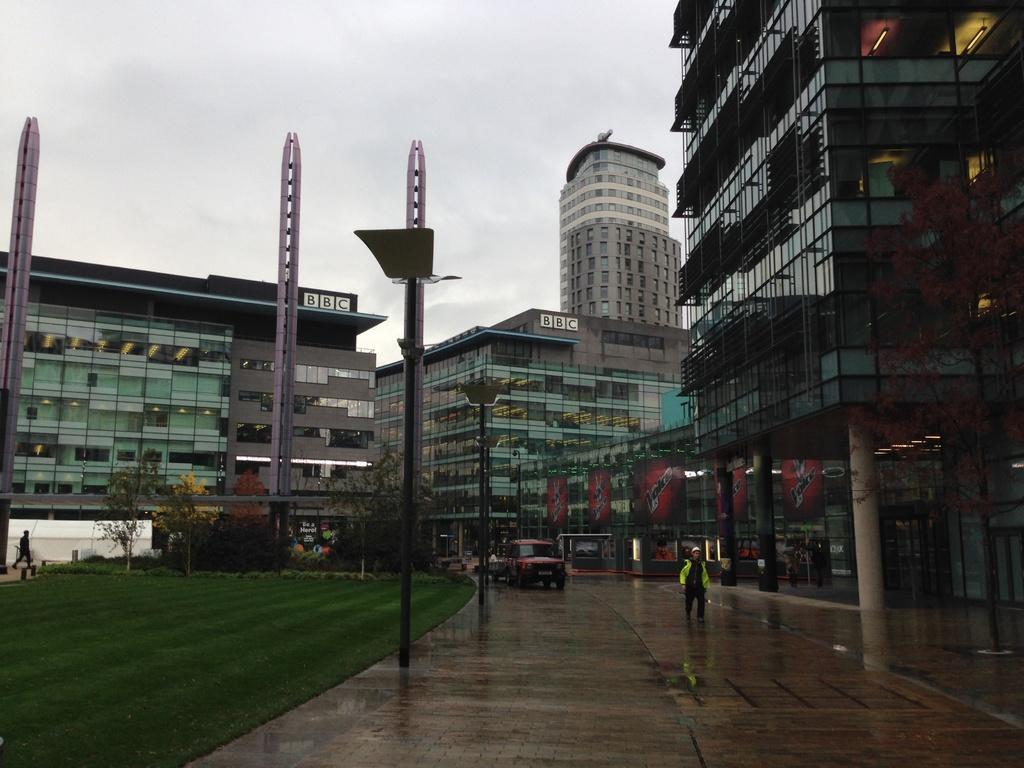Please provide a concise description of this image. In this image there is a road at the bottom. On the road there are vehicles. On the right side there is a man walking on the road by wearing the jacket. In the background there are buildings with the glasses. On the left side there are pillars, There are light poles on the footpath. On the left side there is a ground on which there is grass and some small plants. On the right side there are pillars of the building. 